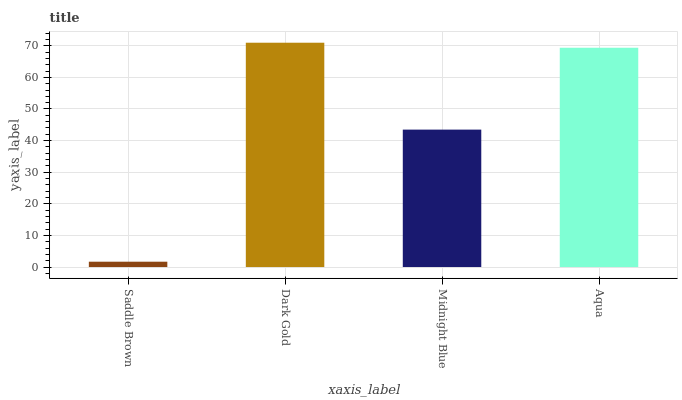Is Saddle Brown the minimum?
Answer yes or no. Yes. Is Dark Gold the maximum?
Answer yes or no. Yes. Is Midnight Blue the minimum?
Answer yes or no. No. Is Midnight Blue the maximum?
Answer yes or no. No. Is Dark Gold greater than Midnight Blue?
Answer yes or no. Yes. Is Midnight Blue less than Dark Gold?
Answer yes or no. Yes. Is Midnight Blue greater than Dark Gold?
Answer yes or no. No. Is Dark Gold less than Midnight Blue?
Answer yes or no. No. Is Aqua the high median?
Answer yes or no. Yes. Is Midnight Blue the low median?
Answer yes or no. Yes. Is Dark Gold the high median?
Answer yes or no. No. Is Saddle Brown the low median?
Answer yes or no. No. 